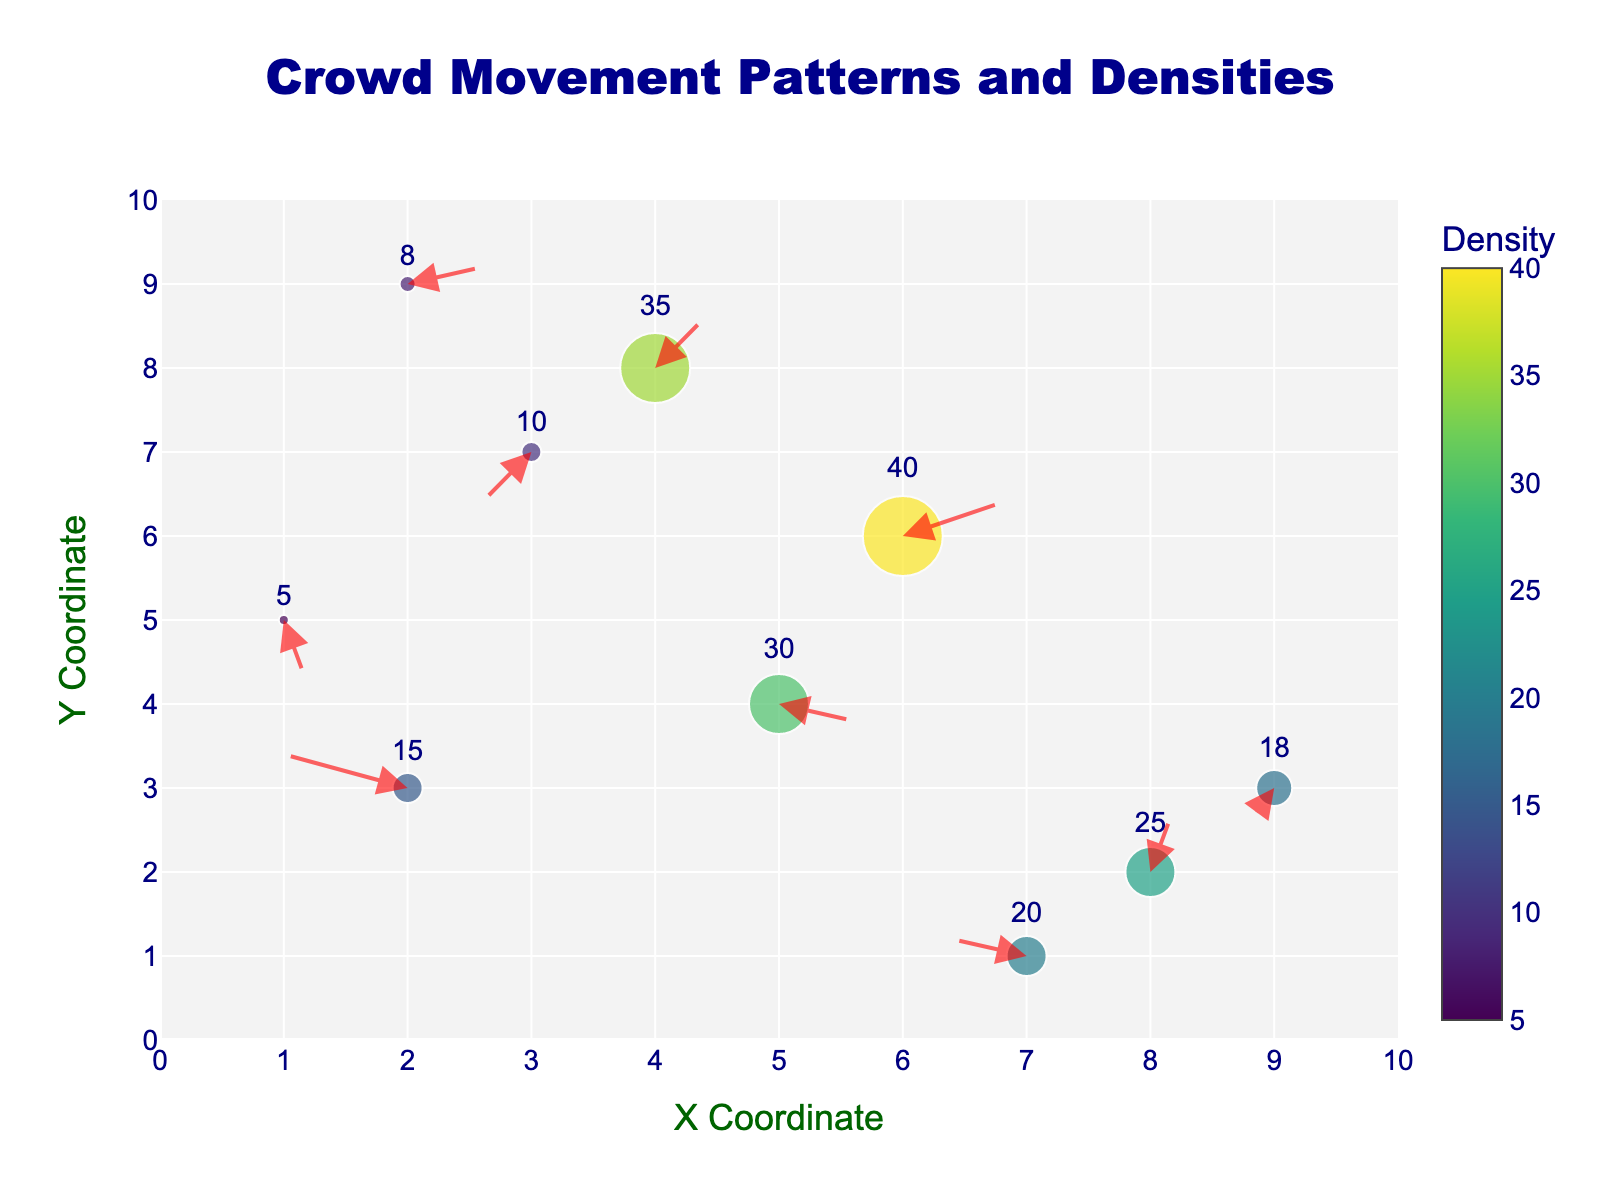What is the title of the figure? The title is located at the top of the figure, written in a prominent font.
Answer: Crowd Movement Patterns and Densities How many arrows are pointing downward on the right half of the plot? The right half of the plot has x-coordinates greater than 5. There are arrows at (6, 6) and (9, 3) pointing downward.
Answer: Two Which data point has the highest density? Comparing the densities of all points, the highest density is labeled as 40. This corresponds to the coordinates (6, 6).
Answer: (6, 6) What direction is the arrow at (8, 2) pointing? The given u and v values for the (8, 2) data point produce the arrow's direction. Here, u = 0.1 and v = 0.4 indicate an upward and slightly right direction.
Answer: Upward and right Which data point has the largest arrow? The length of the arrow is determined by the vectors u and v. The largest arrow would have the highest magnitude of the vector sum sqrt(u^2 + v^2). Calculating this for each point, the (6, 6) point with u = 0.4 and v = 0.2 gives the longest arrow with sqrt(0.4^2 + 0.2^2) = sqrt(0.16 + 0.04) ≈ 0.45.
Answer: (6, 6) Where is the least dense area in the figure? The density is indicated by the size of the markers. The least dense area corresponds to the lowest density value, which is 5 at coordinates (1, 5).
Answer: (1, 5) Which direction is the crowd mostly moving in at the highest density point? The point with the highest density is at (6, 6) with density 40. Its arrow has u = 0.4 and v = 0.2, pointing mostly right and slightly upward.
Answer: Right and slightly upward What is the coordinate pair of the point that has an arrow pointing directly to the left? An arrow pointing directly to the left would have u < 0 and v = 0. Reviewing all points with those conditions, (7, 1) has u = -0.3 and v = 0.1. The v value isn't exactly zero but close enough.
Answer: (7, 1) Which data point has the shortest arrow? By calculating the vector magnitude, the shortest arrow is determined. The point (9, 3) with u = -0.1 and v = -0.2 gives sqrt((-0.1)^2 + (-0.2)^2) = sqrt(0.01 + 0.04) = sqrt(0.05) ≈ 0.22. This is the shortest arrow in the plot.
Answer: (9, 3) How many data points have negative x or y directional components? To find this, count the points where either u < 0 or v < 0. These points are (2, 3), (3, 7), (1, 5), (7, 1), and (9, 3), making a total of 5 data points.
Answer: Five 